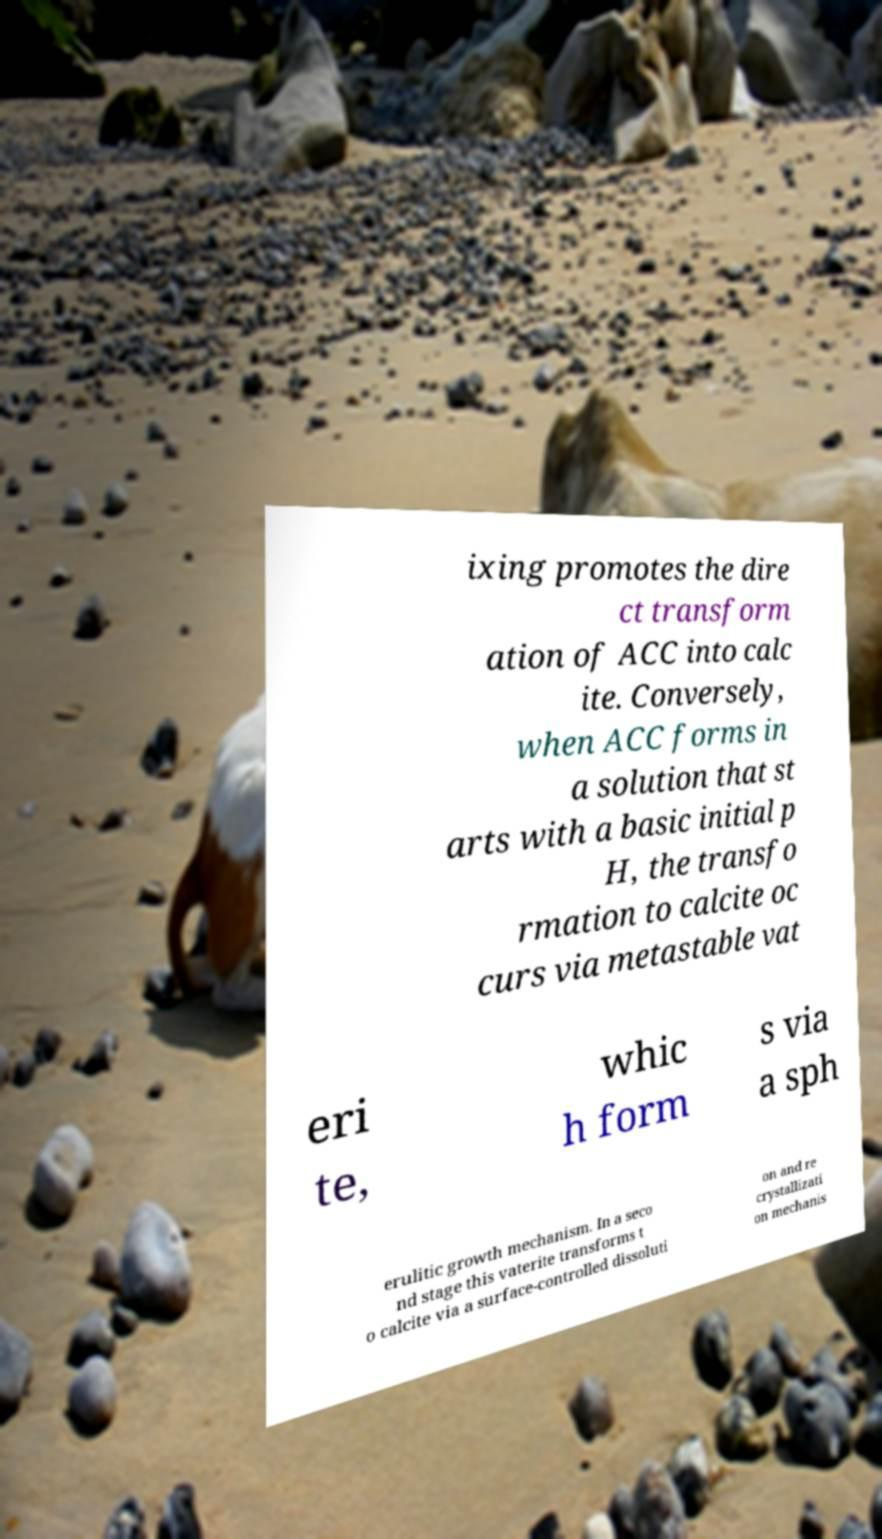Can you read and provide the text displayed in the image?This photo seems to have some interesting text. Can you extract and type it out for me? ixing promotes the dire ct transform ation of ACC into calc ite. Conversely, when ACC forms in a solution that st arts with a basic initial p H, the transfo rmation to calcite oc curs via metastable vat eri te, whic h form s via a sph erulitic growth mechanism. In a seco nd stage this vaterite transforms t o calcite via a surface-controlled dissoluti on and re crystallizati on mechanis 